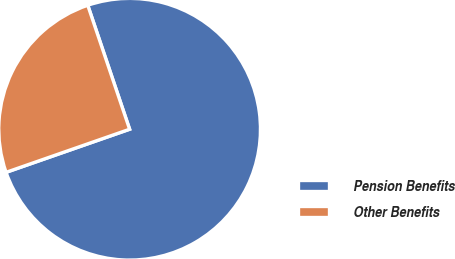<chart> <loc_0><loc_0><loc_500><loc_500><pie_chart><fcel>Pension Benefits<fcel>Other Benefits<nl><fcel>74.84%<fcel>25.16%<nl></chart> 